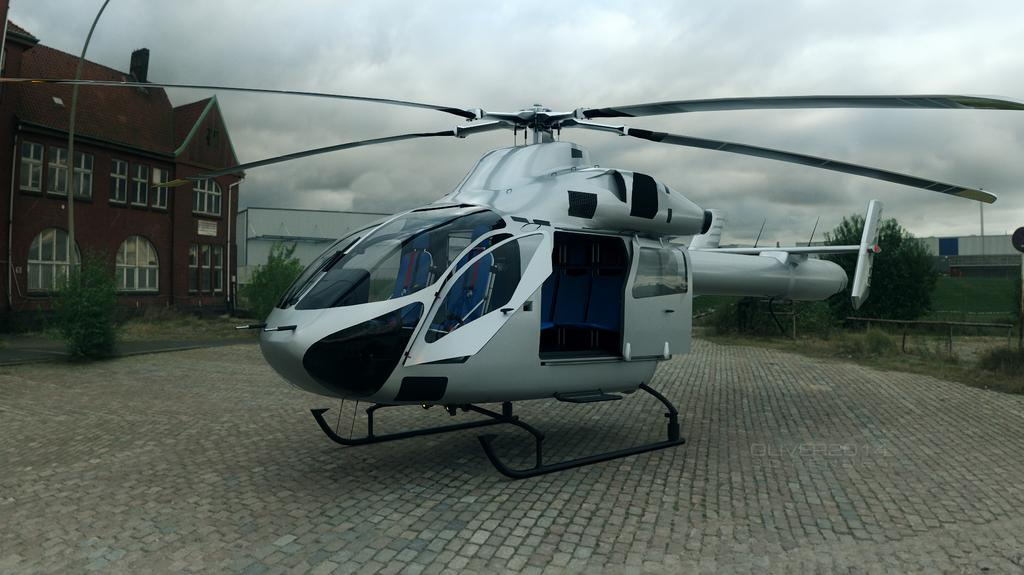What is the main subject of the image? The main subject of the image is a helicopter. What colors can be seen on the helicopter? The helicopter is white, black, and blue in color. Where is the helicopter located in the image? The helicopter is on the ground. What can be seen in the background of the image? There are buildings, trees, and the sky visible in the background of the image. What type of show is being performed in the bedroom at night in the image? There is no bedroom or nighttime scene depicted in the image; it features a helicopter on the ground with buildings, trees, and the sky in the background. 